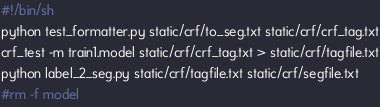<code> <loc_0><loc_0><loc_500><loc_500><_Bash_>#!/bin/sh
python test_formatter.py static/crf/to_seg.txt static/crf/crf_tag.txt
crf_test -m train1.model static/crf/crf_tag.txt > static/crf/tagfile.txt
python label_2_seg.py static/crf/tagfile.txt static/crf/segfile.txt
#rm -f model
</code> 